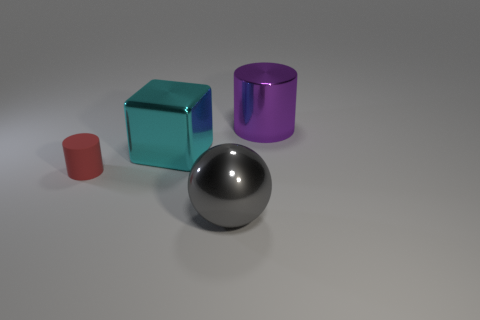Are the red cylinder and the big cyan thing made of the same material?
Give a very brief answer. No. There is a cylinder that is behind the tiny red rubber thing; what number of purple things are behind it?
Ensure brevity in your answer.  0. Are there any other small red rubber objects that have the same shape as the matte object?
Your response must be concise. No. Do the metal object behind the cyan metal cube and the large metal object that is in front of the cyan metal block have the same shape?
Give a very brief answer. No. There is a big shiny thing that is both right of the large block and behind the large gray object; what is its shape?
Offer a very short reply. Cylinder. Is there another cylinder that has the same size as the red cylinder?
Offer a terse response. No. There is a shiny cylinder; does it have the same color as the tiny matte cylinder that is to the left of the big cube?
Your response must be concise. No. What is the block made of?
Keep it short and to the point. Metal. What color is the metal thing that is in front of the matte cylinder?
Give a very brief answer. Gray. What number of shiny cubes are the same color as the large cylinder?
Your answer should be compact. 0. 